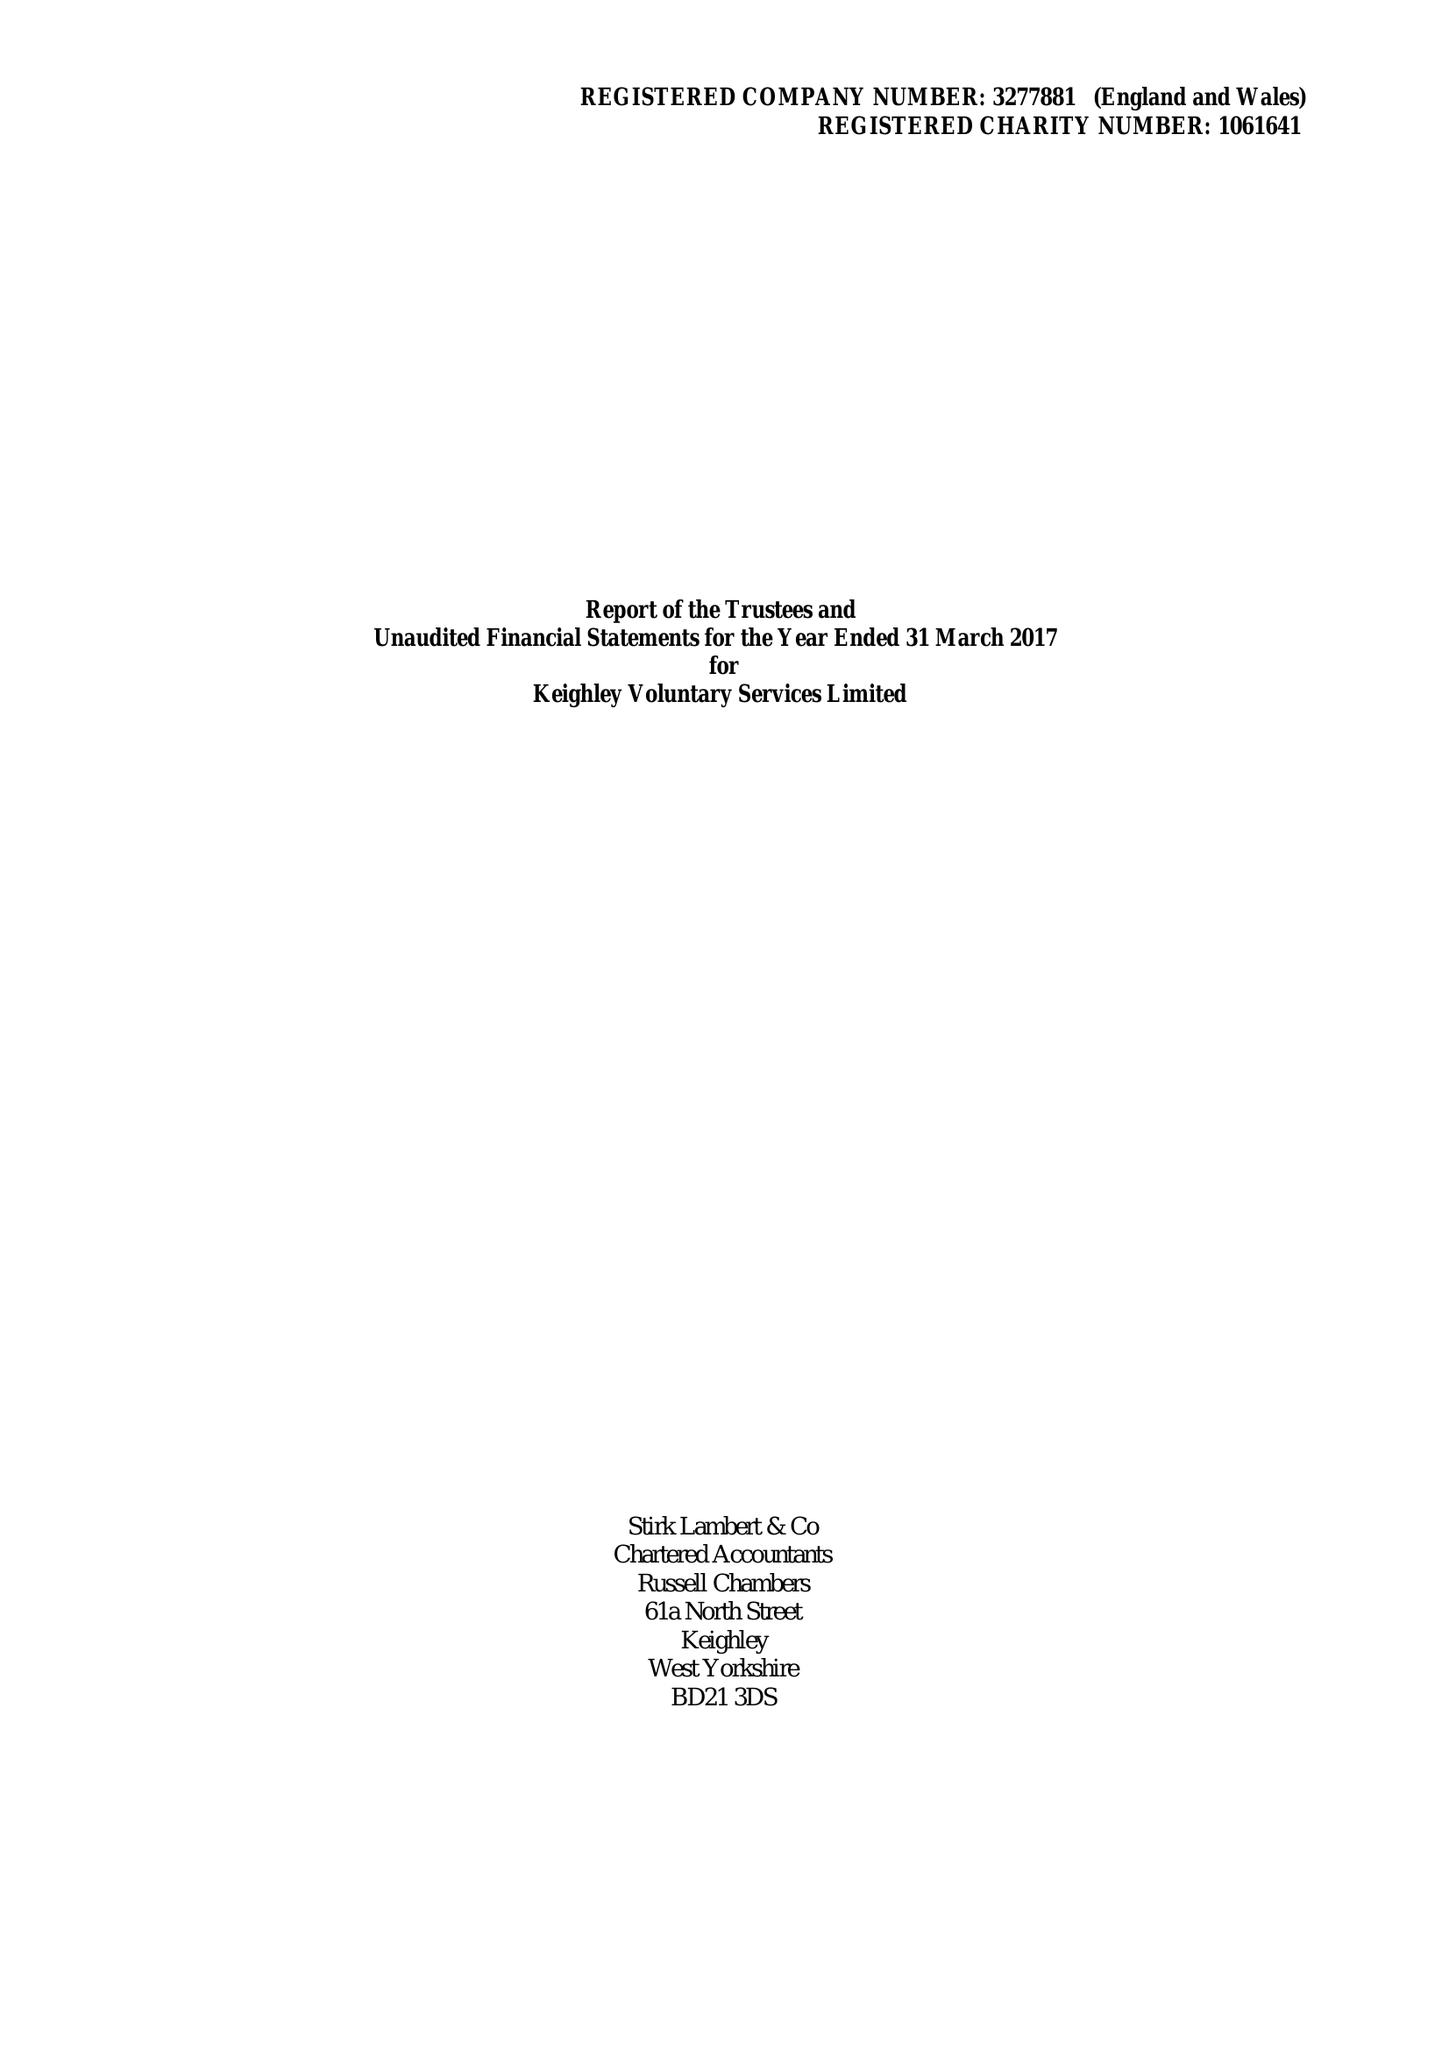What is the value for the address__street_line?
Answer the question using a single word or phrase. ALICE STREET 